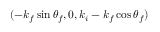Convert formula to latex. <formula><loc_0><loc_0><loc_500><loc_500>( - k _ { f } \sin \theta _ { f } , 0 , k _ { i } - k _ { f } \cos \theta _ { f } )</formula> 